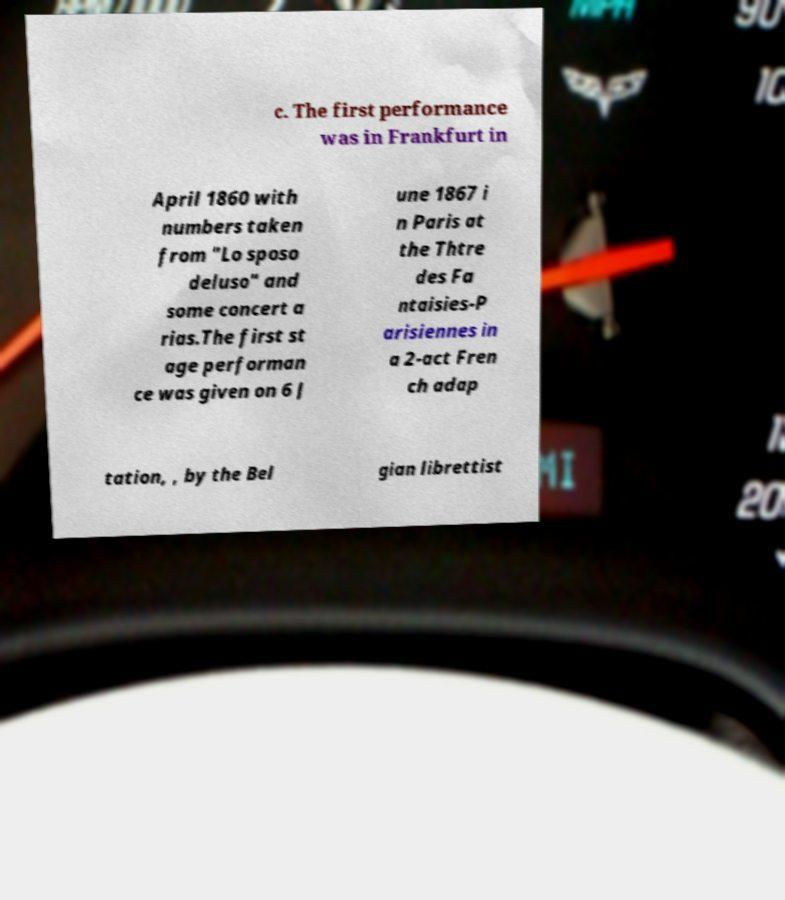For documentation purposes, I need the text within this image transcribed. Could you provide that? c. The first performance was in Frankfurt in April 1860 with numbers taken from "Lo sposo deluso" and some concert a rias.The first st age performan ce was given on 6 J une 1867 i n Paris at the Thtre des Fa ntaisies-P arisiennes in a 2-act Fren ch adap tation, , by the Bel gian librettist 